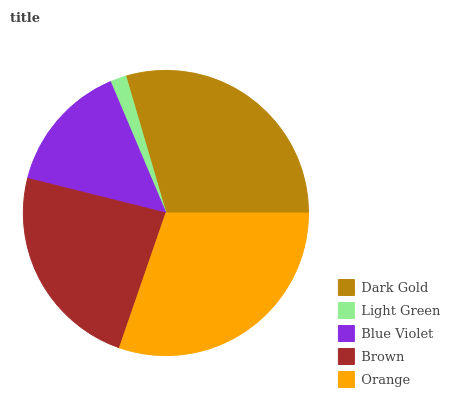Is Light Green the minimum?
Answer yes or no. Yes. Is Orange the maximum?
Answer yes or no. Yes. Is Blue Violet the minimum?
Answer yes or no. No. Is Blue Violet the maximum?
Answer yes or no. No. Is Blue Violet greater than Light Green?
Answer yes or no. Yes. Is Light Green less than Blue Violet?
Answer yes or no. Yes. Is Light Green greater than Blue Violet?
Answer yes or no. No. Is Blue Violet less than Light Green?
Answer yes or no. No. Is Brown the high median?
Answer yes or no. Yes. Is Brown the low median?
Answer yes or no. Yes. Is Blue Violet the high median?
Answer yes or no. No. Is Dark Gold the low median?
Answer yes or no. No. 